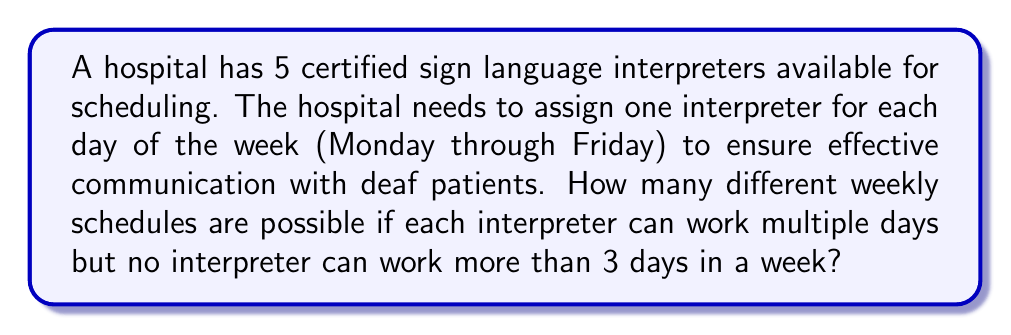Give your solution to this math problem. Let's approach this step-by-step:

1) We have 5 interpreters to choose from for each of the 5 weekdays.

2) For each day, we have 5 choices, as any interpreter can work on any day.

3) However, we need to consider the constraint that no interpreter can work more than 3 days in a week.

4) This problem can be solved using the multiplication principle and the inclusion-exclusion principle.

5) First, let's count all possible schedules without the constraint:
   $5^5 = 3125$ (5 choices for each of 5 days)

6) Now, we need to subtract the schedules where at least one interpreter works more than 3 days.

7) For an interpreter to work more than 3 days, they must work either 4 or 5 days.

8) Number of ways an interpreter can work 4 specific days: $1 \cdot 5 = 5$ (1 way for the 4 specified days, 5 choices for the remaining day)

9) Number of ways an interpreter can work all 5 days: $1$

10) Number of ways to choose 4 days out of 5: $\binom{5}{4} = 5$

11) Number of ways to choose 5 days out of 5: $\binom{5}{5} = 1$

12) Total number of schedules where at least one interpreter works more than 3 days:
    $5 \cdot (5 \cdot 5 + 1) = 130$

13) Therefore, the number of valid schedules is:
    $3125 - 130 = 2995$
Answer: 2995 